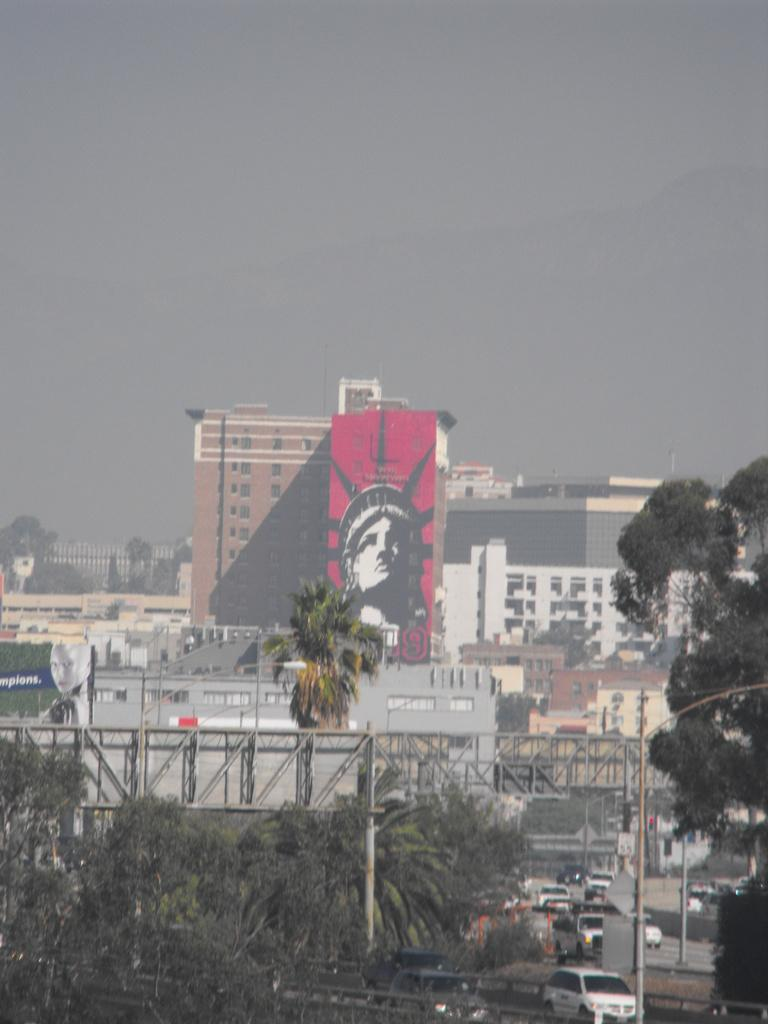What can be seen in the image that represents human-made structures? There are many buildings in the image. What is happening on the road in the image? There are a lot of vehicles on the road in the image. What is the purpose of the structure above the road? There is a bridge above the road in the image. What type of natural elements can be seen around the bridge? There are many trees around the bridge in the image. Can you tell me how many beans are scattered on the bridge in the image? There are no beans present in the image; it features buildings, vehicles, a bridge, and trees. 